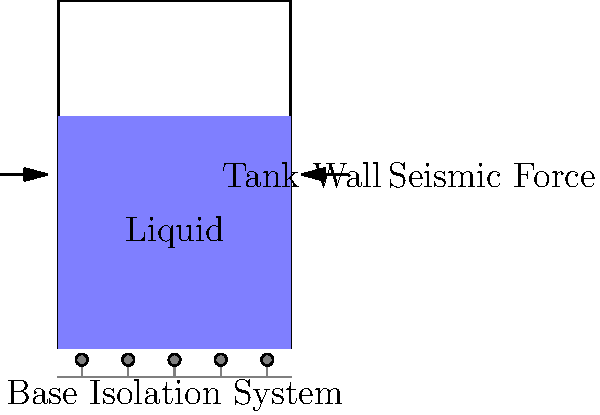As an oil refinery owner, you're planning to upgrade your storage facilities to withstand seismic activities. The proposed design includes a base isolation system for a cylindrical storage tank. If the tank has a diameter of 20 meters and a height of 15 meters, what is the minimum thickness of the tank wall to resist a horizontal seismic force of 0.3g, assuming the tank is 80% full of crude oil (density 850 kg/m³)? Use the hoop stress formula $$\sigma = \frac{pr}{t}$$, where p is the pressure, r is the radius, and t is the thickness. The yield strength of the steel used is 250 MPa, and a safety factor of 2 is required. To determine the minimum wall thickness, we'll follow these steps:

1. Calculate the total force acting on the tank:
   - Volume of oil: $V = \pi r^2 h \times 0.8 = \pi \times 10^2 \times 15 \times 0.8 = 3770.35 \text{ m}^3$
   - Mass of oil: $m = \rho V = 850 \times 3770.35 = 3,204,797.5 \text{ kg}$
   - Seismic force: $F = ma = 3,204,797.5 \times 0.3g = 9,614,392.5 \text{ N}$

2. Calculate the pressure exerted on the tank wall:
   $p = \frac{F}{A} = \frac{9,614,392.5}{2\pi r h} = \frac{9,614,392.5}{2\pi \times 10 \times 15} = 10,204.08 \text{ Pa}$

3. Use the hoop stress formula to calculate the required thickness:
   $\sigma = \frac{pr}{t}$
   $t = \frac{pr}{\sigma}$

   Where $\sigma$ is the allowable stress (yield strength divided by safety factor):
   $\sigma = \frac{250 \times 10^6}{2} = 125 \times 10^6 \text{ Pa}$

4. Substitute values:
   $t = \frac{10,204.08 \times 10}{125 \times 10^6} = 0.000816 \text{ m} = 0.816 \text{ mm}$

5. Round up to the nearest practical thickness:
   Minimum thickness ≈ 1 mm
Answer: 1 mm 